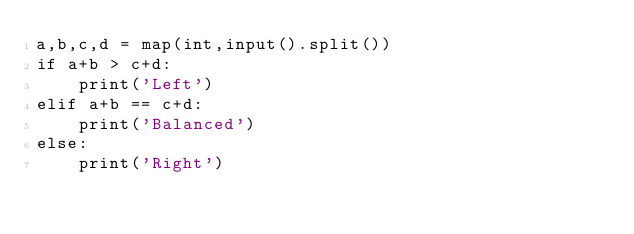Convert code to text. <code><loc_0><loc_0><loc_500><loc_500><_Python_>a,b,c,d = map(int,input().split())
if a+b > c+d:
    print('Left')
elif a+b == c+d:
    print('Balanced')
else:
    print('Right')</code> 